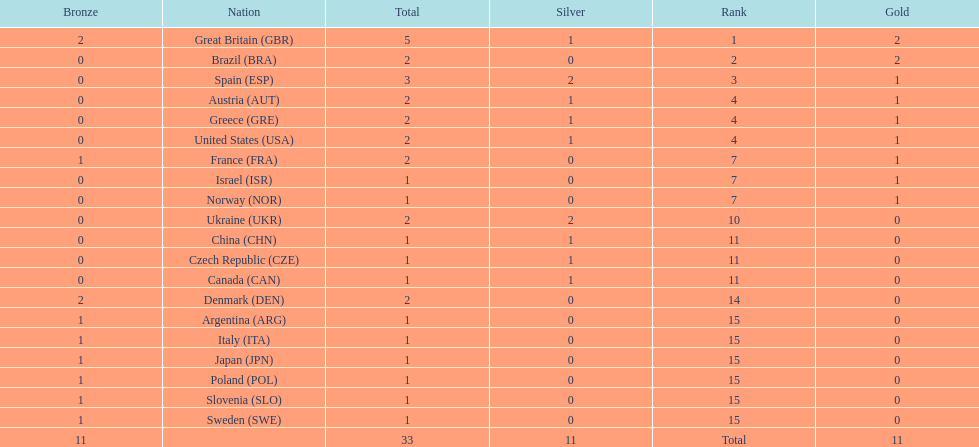How many medals in total has the united states achieved? 2. 